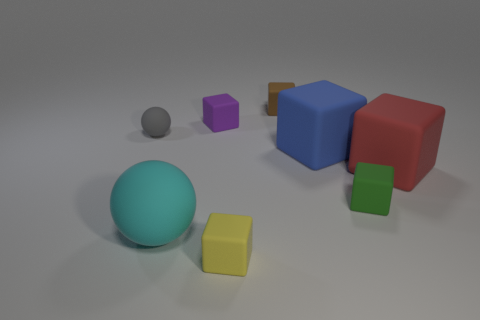How many objects are both left of the tiny green cube and on the right side of the small brown cube?
Offer a terse response. 1. How many things are small brown things or small matte things that are on the left side of the cyan object?
Make the answer very short. 2. Is the number of gray spheres greater than the number of large gray cylinders?
Offer a very short reply. Yes. There is a large matte thing on the right side of the blue cube; what is its shape?
Your response must be concise. Cube. How many small yellow matte things are the same shape as the brown matte thing?
Offer a terse response. 1. There is a rubber ball that is in front of the small rubber cube that is to the right of the blue object; what is its size?
Keep it short and to the point. Large. What number of green things are either spheres or matte cubes?
Provide a short and direct response. 1. Is the number of big cyan balls that are to the right of the brown rubber cube less than the number of balls that are behind the blue rubber thing?
Keep it short and to the point. Yes. Does the gray object have the same size as the rubber sphere in front of the red matte cube?
Keep it short and to the point. No. What number of green blocks have the same size as the yellow rubber object?
Offer a very short reply. 1. 